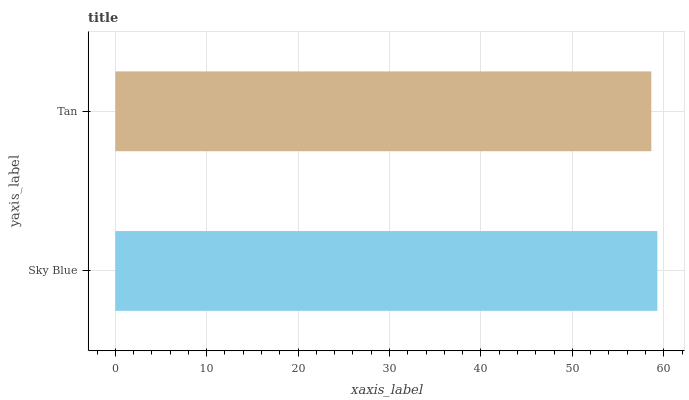Is Tan the minimum?
Answer yes or no. Yes. Is Sky Blue the maximum?
Answer yes or no. Yes. Is Tan the maximum?
Answer yes or no. No. Is Sky Blue greater than Tan?
Answer yes or no. Yes. Is Tan less than Sky Blue?
Answer yes or no. Yes. Is Tan greater than Sky Blue?
Answer yes or no. No. Is Sky Blue less than Tan?
Answer yes or no. No. Is Sky Blue the high median?
Answer yes or no. Yes. Is Tan the low median?
Answer yes or no. Yes. Is Tan the high median?
Answer yes or no. No. Is Sky Blue the low median?
Answer yes or no. No. 